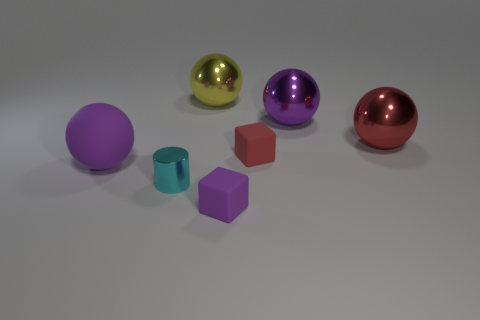Subtract all purple cylinders. How many purple spheres are left? 2 Subtract all red spheres. How many spheres are left? 3 Subtract all matte balls. How many balls are left? 3 Add 1 small red cubes. How many objects exist? 8 Subtract all cylinders. How many objects are left? 6 Subtract all yellow spheres. Subtract all brown cubes. How many spheres are left? 3 Subtract 0 brown cubes. How many objects are left? 7 Subtract all big red shiny spheres. Subtract all purple shiny spheres. How many objects are left? 5 Add 5 tiny metal objects. How many tiny metal objects are left? 6 Add 5 cyan cubes. How many cyan cubes exist? 5 